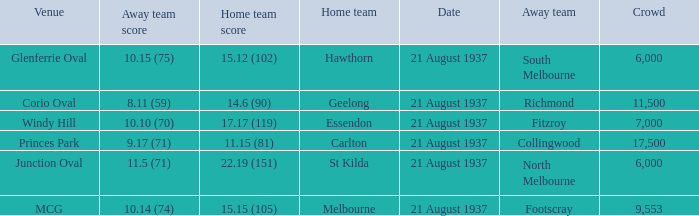Where did Richmond play? Corio Oval. Parse the full table. {'header': ['Venue', 'Away team score', 'Home team score', 'Home team', 'Date', 'Away team', 'Crowd'], 'rows': [['Glenferrie Oval', '10.15 (75)', '15.12 (102)', 'Hawthorn', '21 August 1937', 'South Melbourne', '6,000'], ['Corio Oval', '8.11 (59)', '14.6 (90)', 'Geelong', '21 August 1937', 'Richmond', '11,500'], ['Windy Hill', '10.10 (70)', '17.17 (119)', 'Essendon', '21 August 1937', 'Fitzroy', '7,000'], ['Princes Park', '9.17 (71)', '11.15 (81)', 'Carlton', '21 August 1937', 'Collingwood', '17,500'], ['Junction Oval', '11.5 (71)', '22.19 (151)', 'St Kilda', '21 August 1937', 'North Melbourne', '6,000'], ['MCG', '10.14 (74)', '15.15 (105)', 'Melbourne', '21 August 1937', 'Footscray', '9,553']]} 